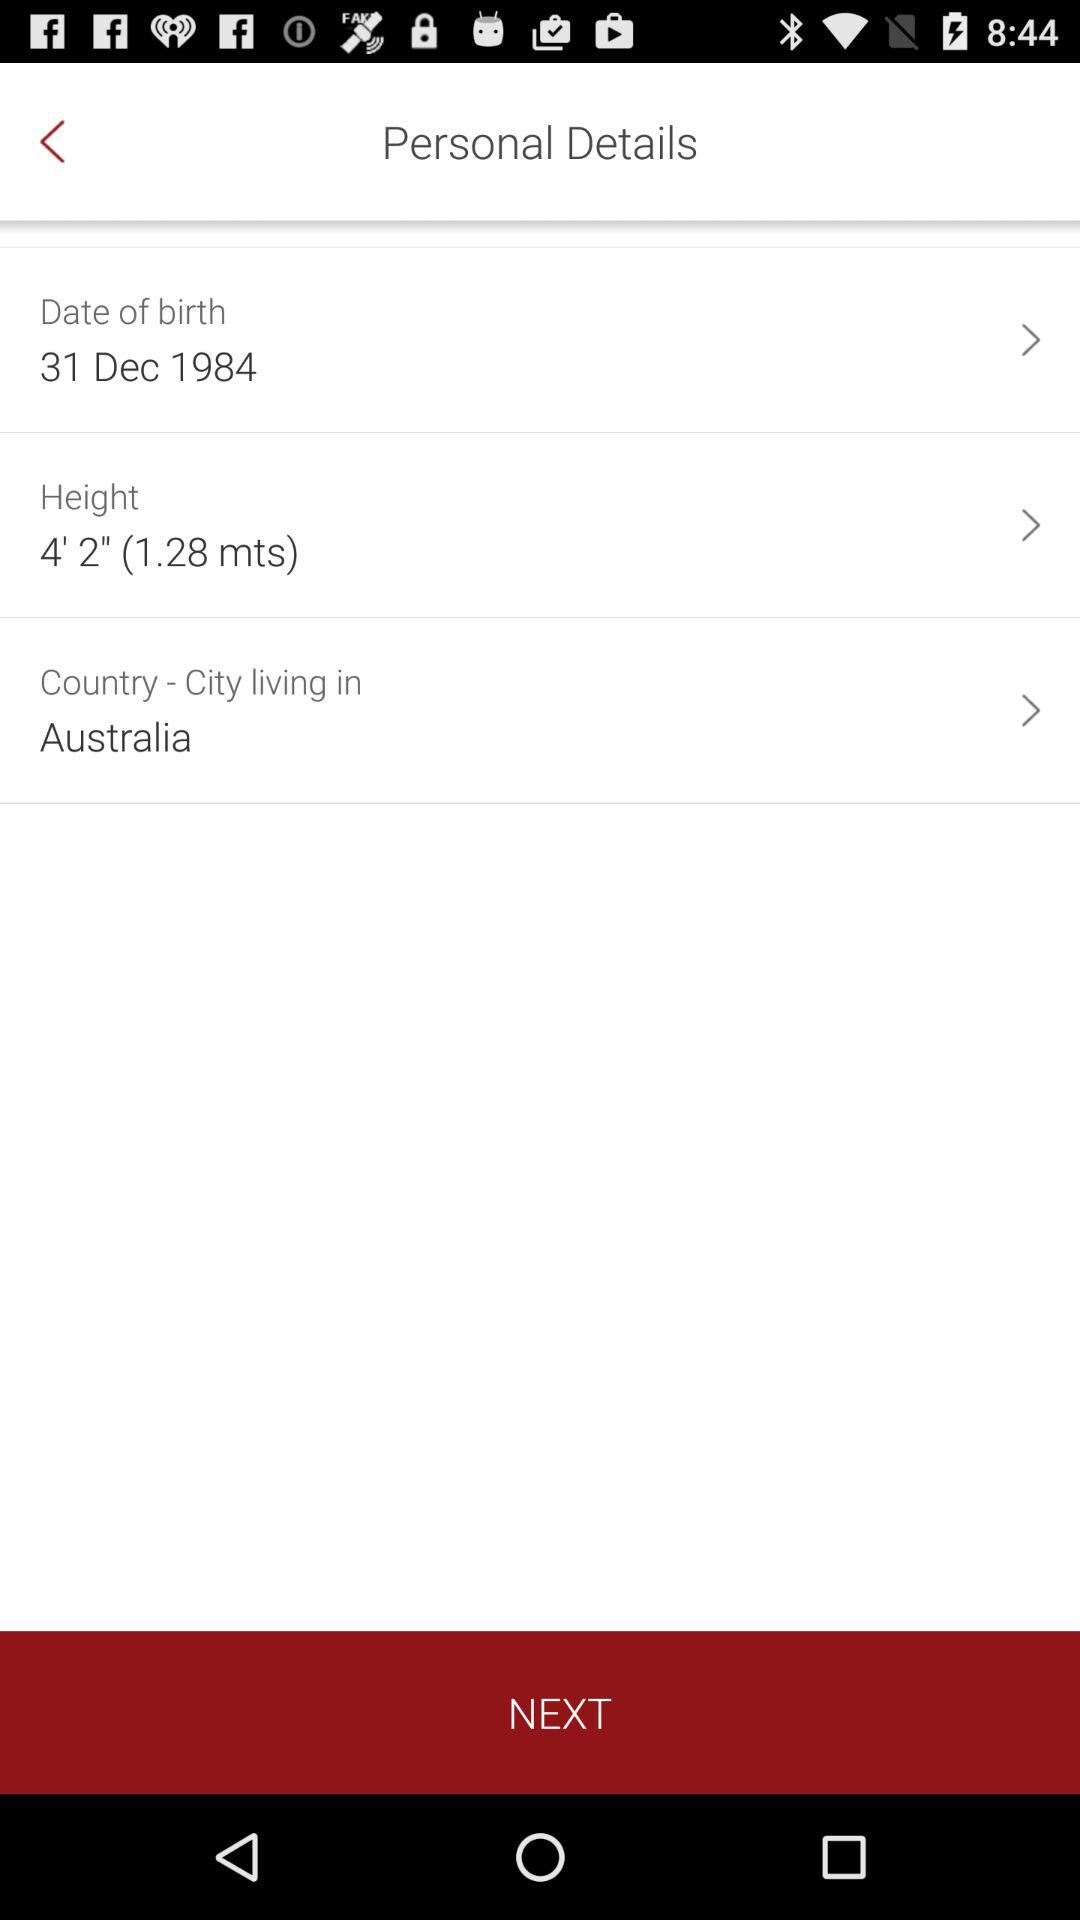How many meters taller is a person who is 1.28 meters tall than a person who is 1.2 meters tall?
Answer the question using a single word or phrase. 0.08 